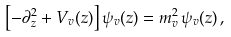<formula> <loc_0><loc_0><loc_500><loc_500>\left [ - \partial _ { z } ^ { 2 } + V _ { v } ( z ) \right ] \psi _ { v } ( z ) = m _ { v } ^ { 2 } \, \psi _ { v } ( z ) \, ,</formula> 